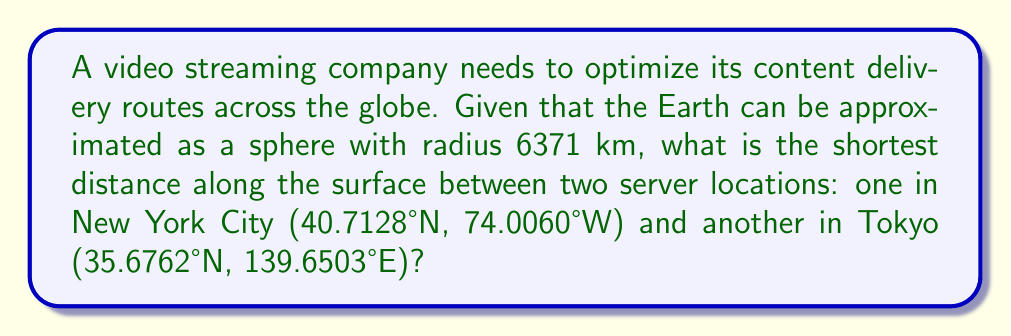Help me with this question. To solve this problem, we need to use the great circle distance formula, which gives the shortest path between two points on a sphere. The steps are as follows:

1. Convert the latitudes and longitudes to radians:
   New York: $\phi_1 = 40.7128° \times \frac{\pi}{180} = 0.7101$ rad
             $\lambda_1 = -74.0060° \times \frac{\pi}{180} = -1.2915$ rad
   Tokyo:    $\phi_2 = 35.6762° \times \frac{\pi}{180} = 0.6226$ rad
             $\lambda_2 = 139.6503° \times \frac{\pi}{180} = 2.4372$ rad

2. Calculate the central angle $\Delta\sigma$ using the Haversine formula:
   $$\Delta\sigma = 2 \arcsin\left(\sqrt{\sin^2\left(\frac{\phi_2 - \phi_1}{2}\right) + \cos\phi_1 \cos\phi_2 \sin^2\left(\frac{\lambda_2 - \lambda_1}{2}\right)}\right)$$

3. Substitute the values:
   $$\Delta\sigma = 2 \arcsin\left(\sqrt{\sin^2\left(\frac{0.6226 - 0.7101}{2}\right) + \cos(0.7101) \cos(0.6226) \sin^2\left(\frac{2.4372 - (-1.2915)}{2}\right)}\right)$$

4. Calculate:
   $$\Delta\sigma = 2 \arcsin(\sqrt{0.0002 + 0.7524 \times 0.7808 \times 0.8887}) = 1.9635$$

5. The distance $d$ along the great circle is given by:
   $$d = R \times \Delta\sigma$$
   where $R$ is the radius of the Earth.

6. Substitute and calculate:
   $$d = 6371 \text{ km} \times 1.9635 = 12,509.91 \text{ km}$$

Therefore, the shortest distance along the surface between the two server locations is approximately 12,510 km.
Answer: 12,510 km 